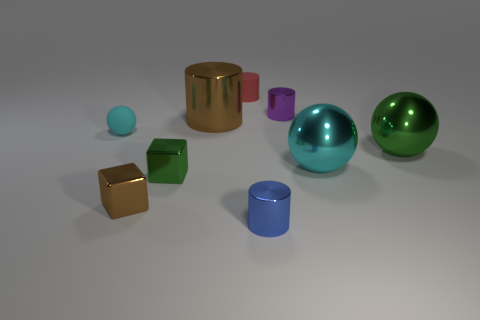Subtract all small red cylinders. How many cylinders are left? 3 Subtract all green spheres. How many spheres are left? 2 Subtract all green blocks. Subtract all brown spheres. How many blocks are left? 1 Subtract all green cubes. How many red spheres are left? 0 Subtract all large brown objects. Subtract all small blue shiny objects. How many objects are left? 7 Add 8 tiny brown shiny cubes. How many tiny brown shiny cubes are left? 9 Add 2 tiny red shiny objects. How many tiny red shiny objects exist? 2 Subtract 1 blue cylinders. How many objects are left? 8 Subtract all blocks. How many objects are left? 7 Subtract 1 cubes. How many cubes are left? 1 